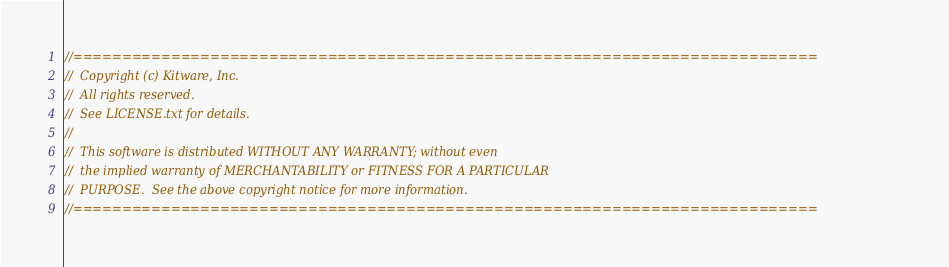<code> <loc_0><loc_0><loc_500><loc_500><_C++_>//============================================================================
//  Copyright (c) Kitware, Inc.
//  All rights reserved.
//  See LICENSE.txt for details.
//
//  This software is distributed WITHOUT ANY WARRANTY; without even
//  the implied warranty of MERCHANTABILITY or FITNESS FOR A PARTICULAR
//  PURPOSE.  See the above copyright notice for more information.
//============================================================================</code> 